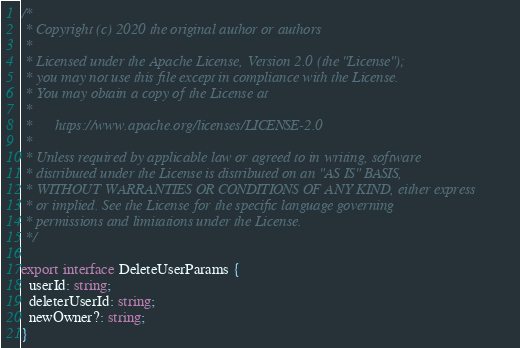<code> <loc_0><loc_0><loc_500><loc_500><_TypeScript_>/*
 * Copyright (c) 2020 the original author or authors
 *
 * Licensed under the Apache License, Version 2.0 (the "License");
 * you may not use this file except in compliance with the License.
 * You may obtain a copy of the License at
 *
 *      https://www.apache.org/licenses/LICENSE-2.0
 *
 * Unless required by applicable law or agreed to in writing, software
 * distributed under the License is distributed on an "AS IS" BASIS,
 * WITHOUT WARRANTIES OR CONDITIONS OF ANY KIND, either express
 * or implied. See the License for the specific language governing
 * permissions and limitations under the License.
 */

export interface DeleteUserParams {
  userId: string;
  deleterUserId: string;
  newOwner?: string;
}
</code> 